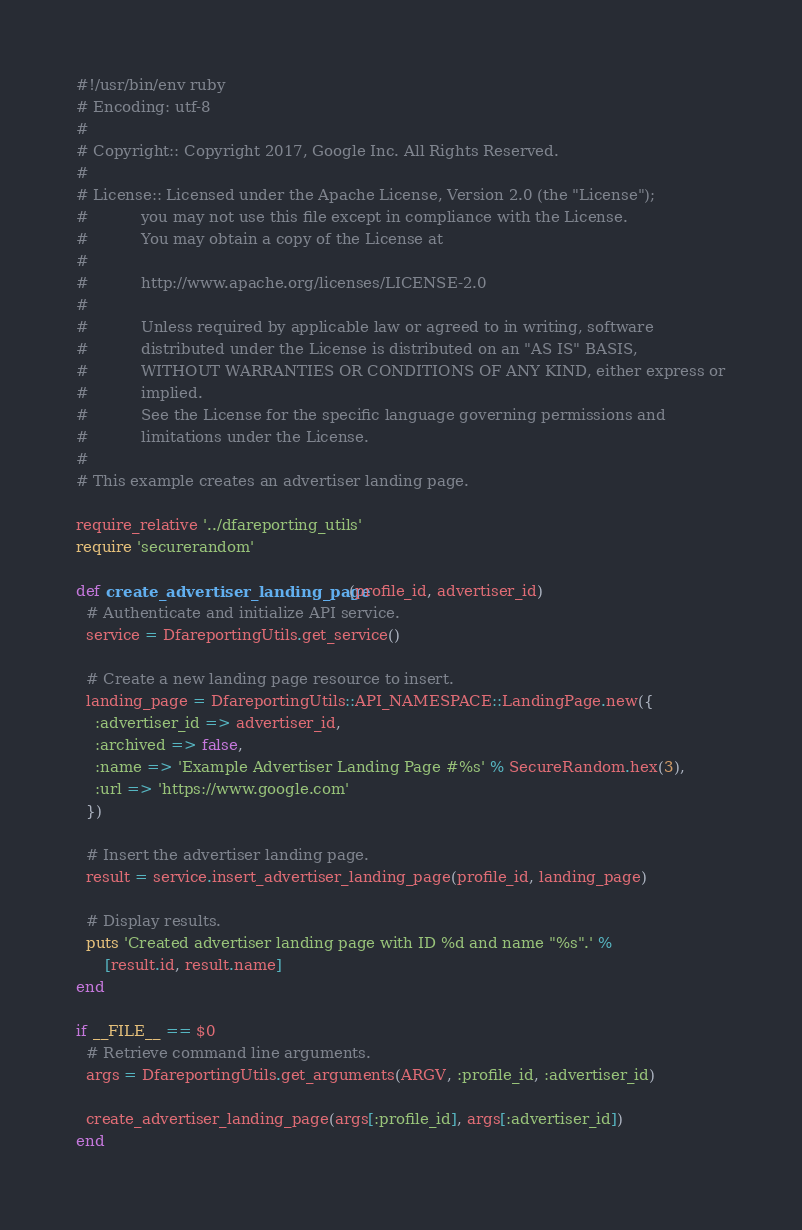Convert code to text. <code><loc_0><loc_0><loc_500><loc_500><_Ruby_>#!/usr/bin/env ruby
# Encoding: utf-8
#
# Copyright:: Copyright 2017, Google Inc. All Rights Reserved.
#
# License:: Licensed under the Apache License, Version 2.0 (the "License");
#           you may not use this file except in compliance with the License.
#           You may obtain a copy of the License at
#
#           http://www.apache.org/licenses/LICENSE-2.0
#
#           Unless required by applicable law or agreed to in writing, software
#           distributed under the License is distributed on an "AS IS" BASIS,
#           WITHOUT WARRANTIES OR CONDITIONS OF ANY KIND, either express or
#           implied.
#           See the License for the specific language governing permissions and
#           limitations under the License.
#
# This example creates an advertiser landing page.

require_relative '../dfareporting_utils'
require 'securerandom'

def create_advertiser_landing_page(profile_id, advertiser_id)
  # Authenticate and initialize API service.
  service = DfareportingUtils.get_service()

  # Create a new landing page resource to insert.
  landing_page = DfareportingUtils::API_NAMESPACE::LandingPage.new({
    :advertiser_id => advertiser_id,
    :archived => false,
    :name => 'Example Advertiser Landing Page #%s' % SecureRandom.hex(3),
    :url => 'https://www.google.com'
  })

  # Insert the advertiser landing page.
  result = service.insert_advertiser_landing_page(profile_id, landing_page)

  # Display results.
  puts 'Created advertiser landing page with ID %d and name "%s".' %
      [result.id, result.name]
end

if __FILE__ == $0
  # Retrieve command line arguments.
  args = DfareportingUtils.get_arguments(ARGV, :profile_id, :advertiser_id)

  create_advertiser_landing_page(args[:profile_id], args[:advertiser_id])
end
</code> 